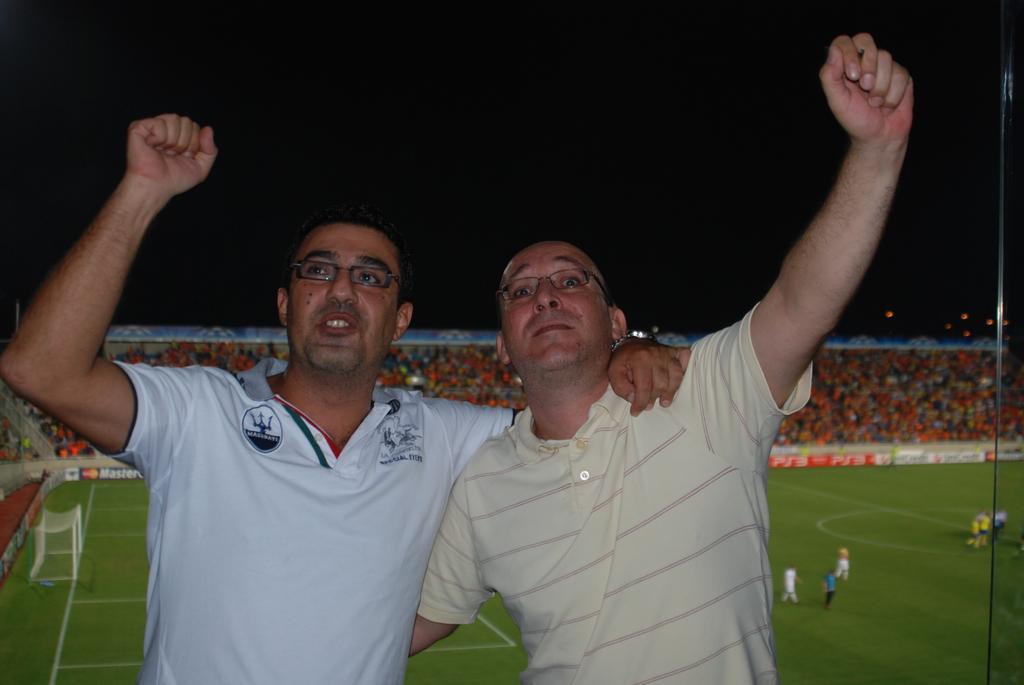Describe this image in one or two sentences. In this image I can see two persons wearing t shirts and spectacles. In the background I can see the ground, few persons, the goalpost, the stadium, number of persons in the stadium and the dark sky. 